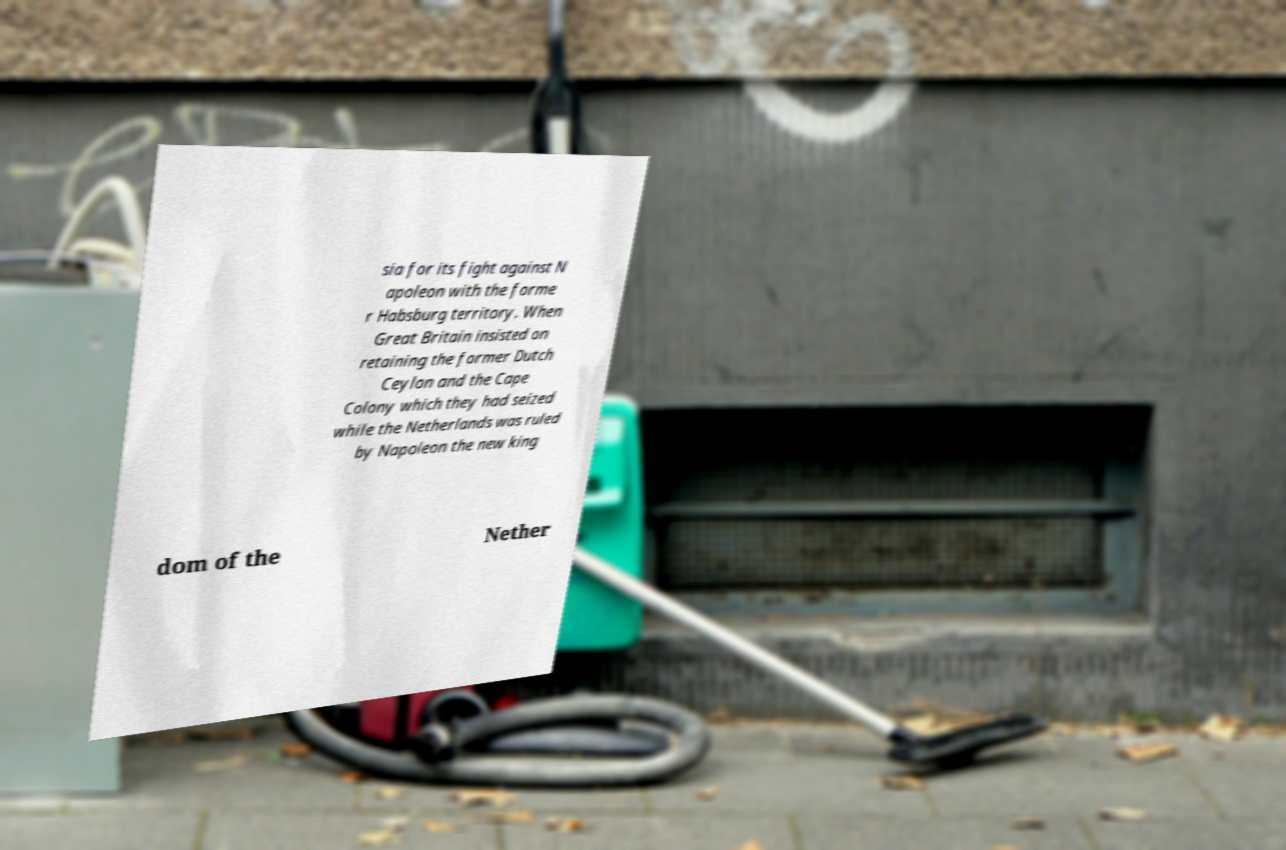I need the written content from this picture converted into text. Can you do that? sia for its fight against N apoleon with the forme r Habsburg territory. When Great Britain insisted on retaining the former Dutch Ceylon and the Cape Colony which they had seized while the Netherlands was ruled by Napoleon the new king dom of the Nether 